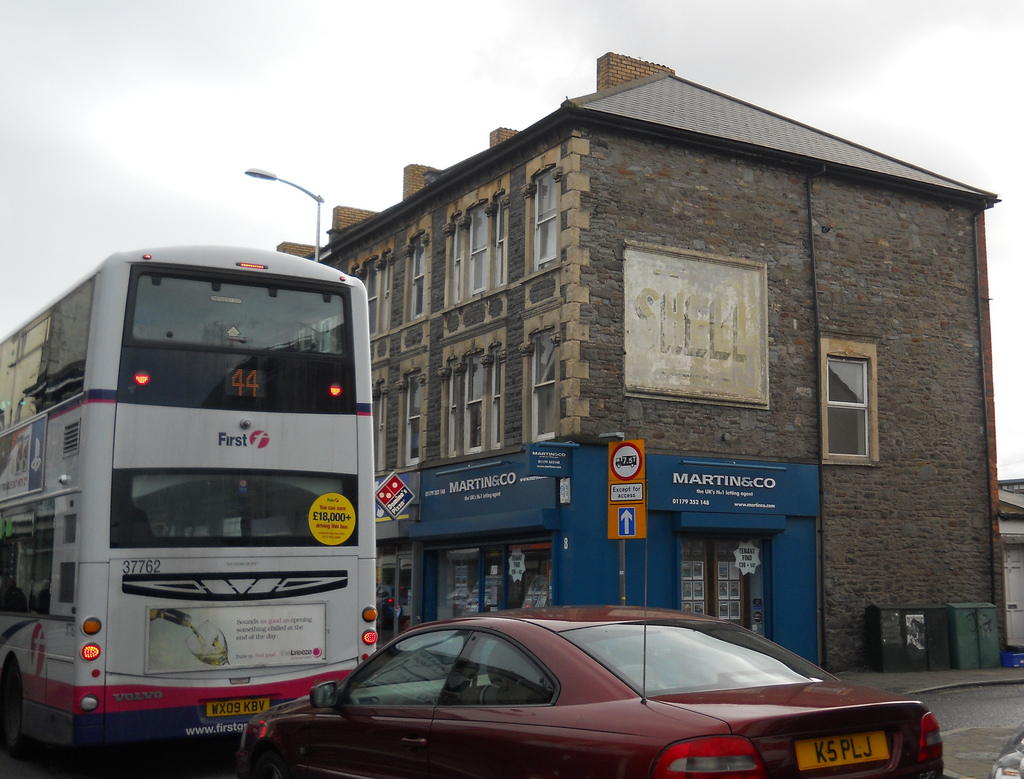Please provide the bounding box coordinate of the region this sentence describes: window on the back of the car. The bounding box coordinate for the window on the back of the car is approximately [0.54, 0.72, 0.82, 0.8]. This identifies the specific region where the rear window of the car is located. 